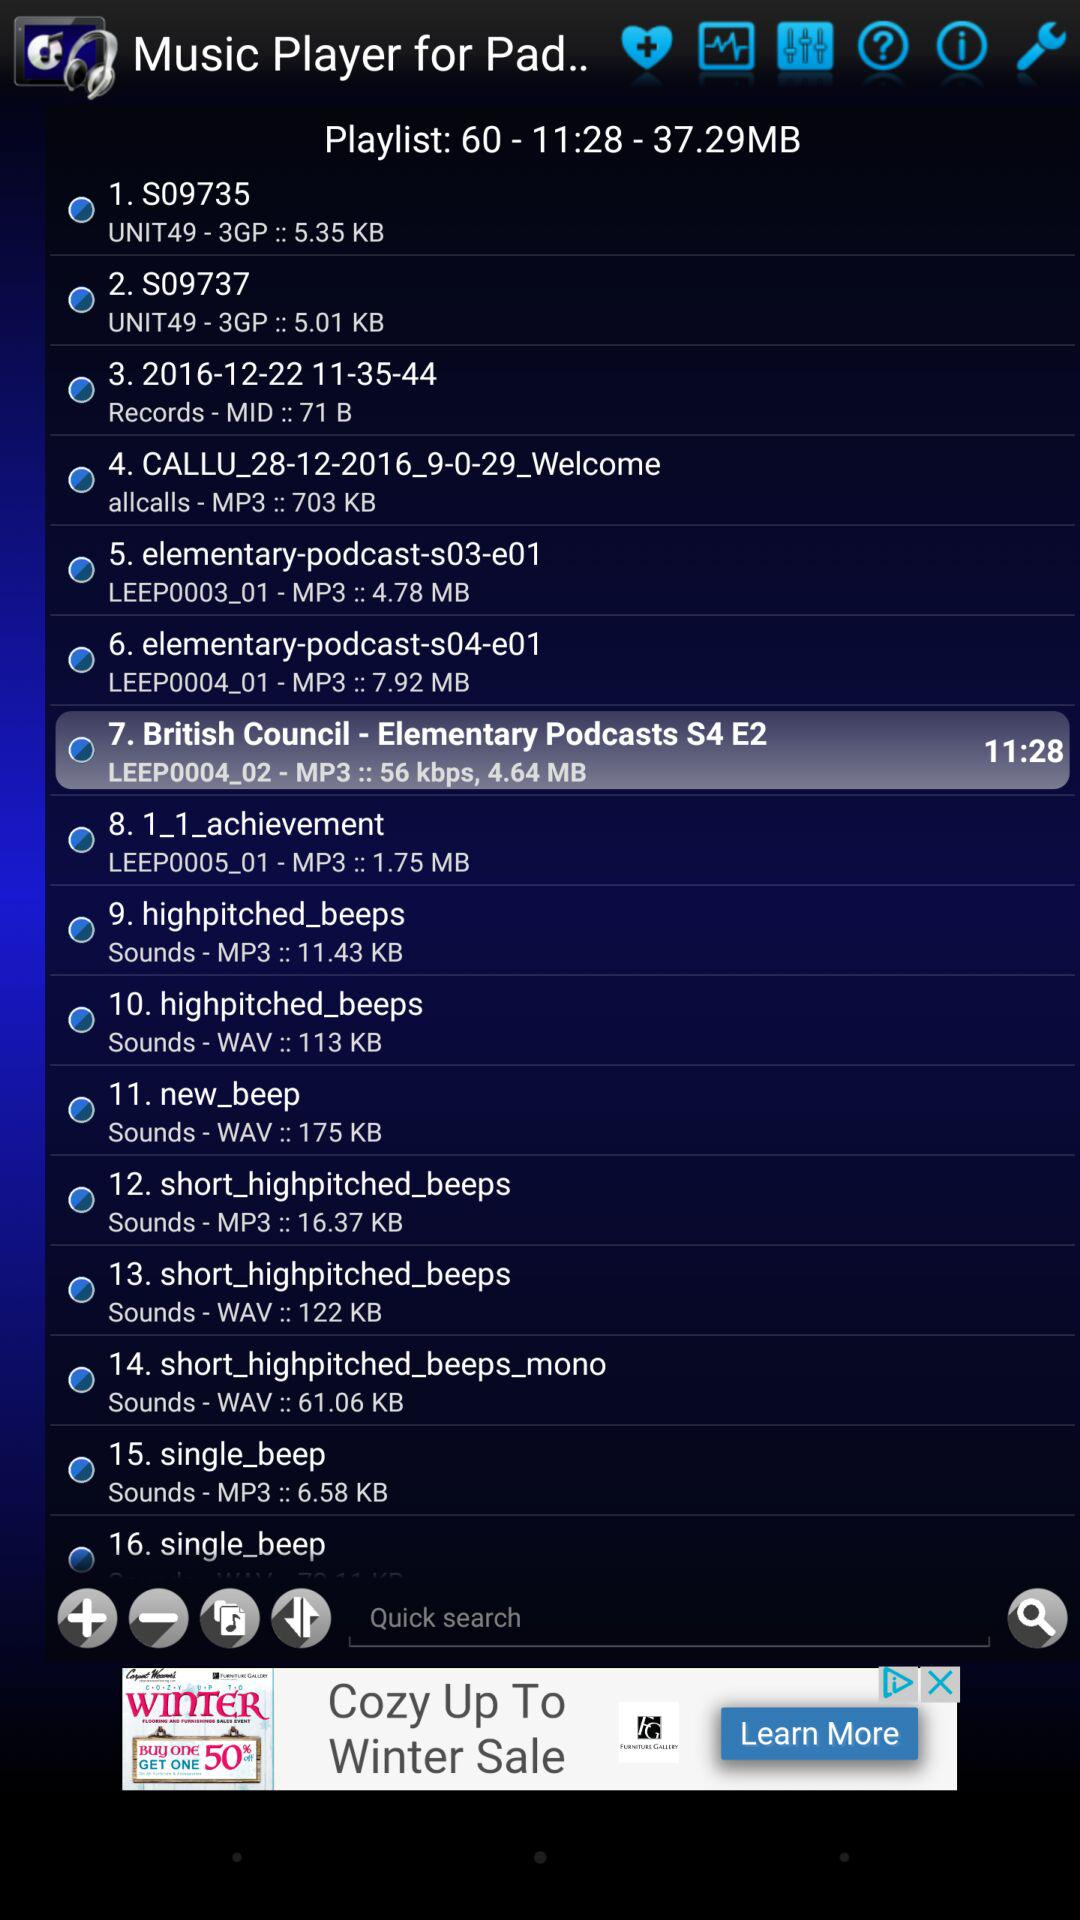What is the size of the 13th audio file? The size of the audio file is 122 KB. 